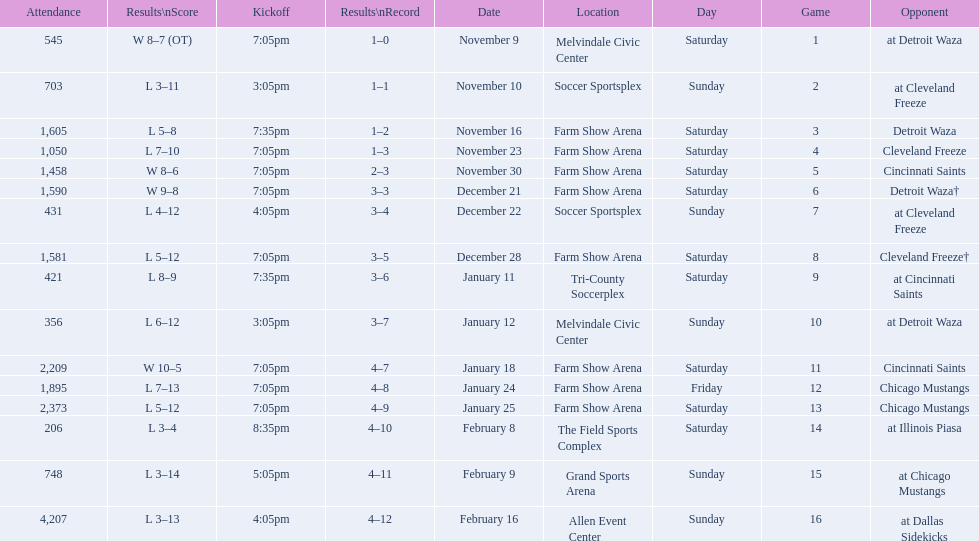Who was the first opponent on this list? Detroit Waza. 